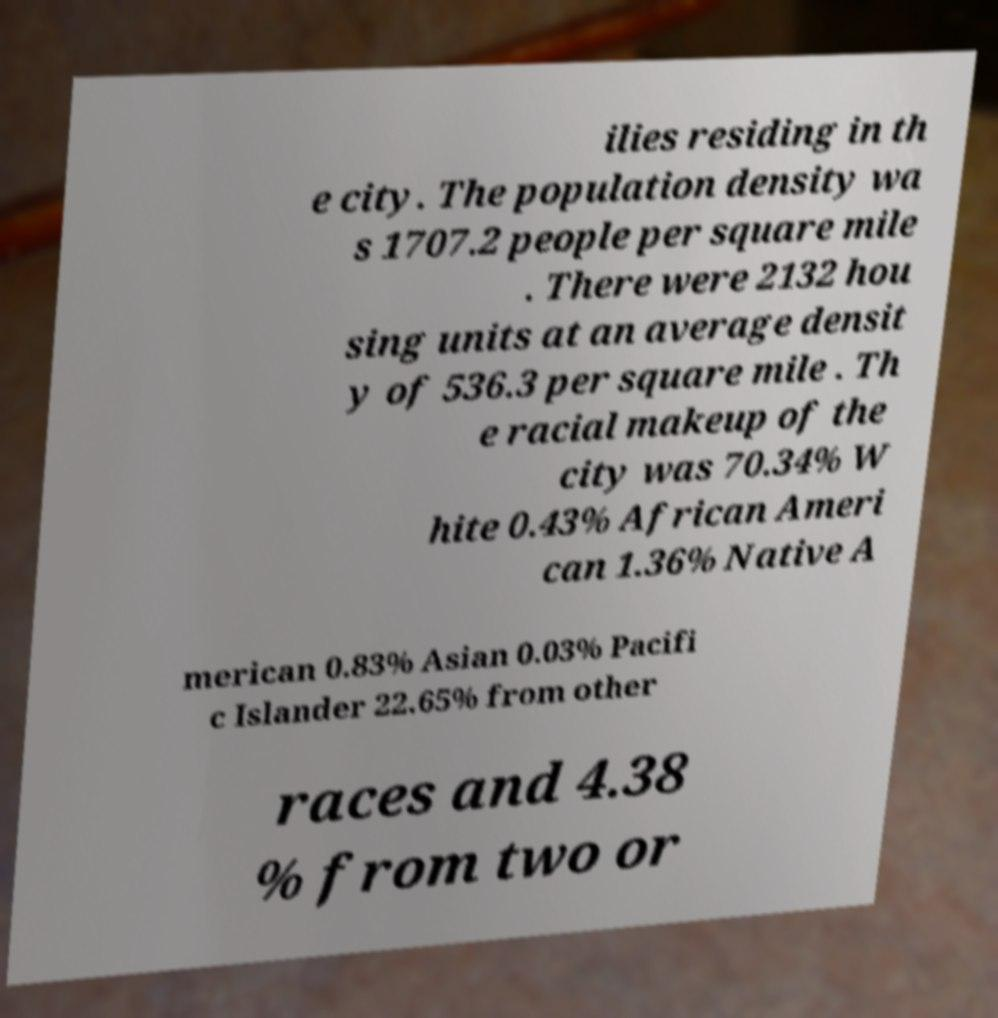I need the written content from this picture converted into text. Can you do that? ilies residing in th e city. The population density wa s 1707.2 people per square mile . There were 2132 hou sing units at an average densit y of 536.3 per square mile . Th e racial makeup of the city was 70.34% W hite 0.43% African Ameri can 1.36% Native A merican 0.83% Asian 0.03% Pacifi c Islander 22.65% from other races and 4.38 % from two or 